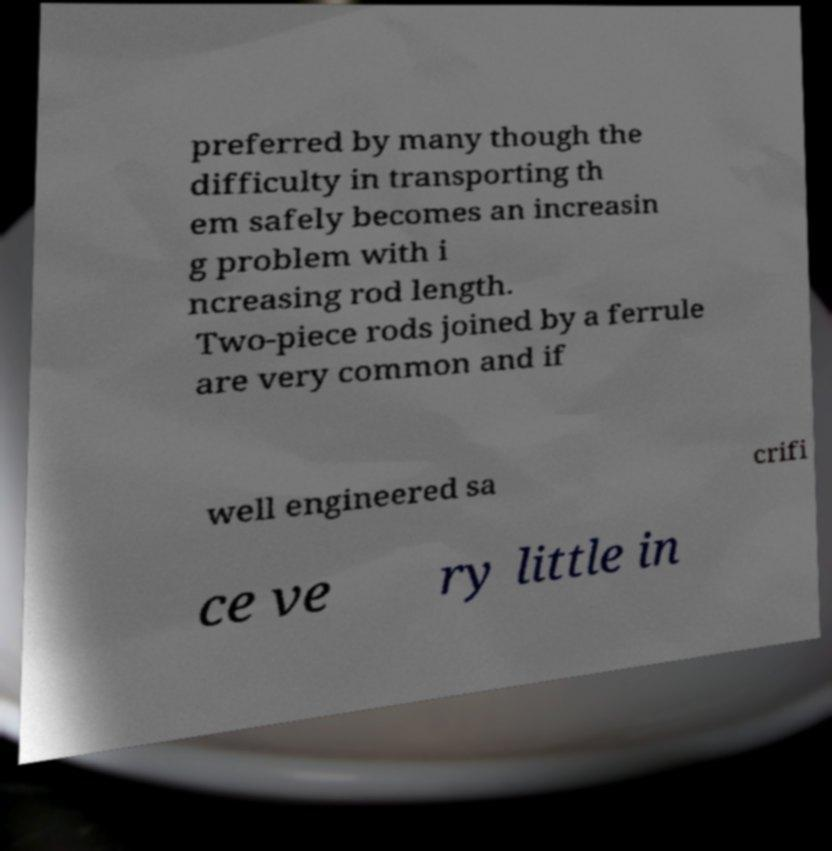Could you extract and type out the text from this image? preferred by many though the difficulty in transporting th em safely becomes an increasin g problem with i ncreasing rod length. Two-piece rods joined by a ferrule are very common and if well engineered sa crifi ce ve ry little in 